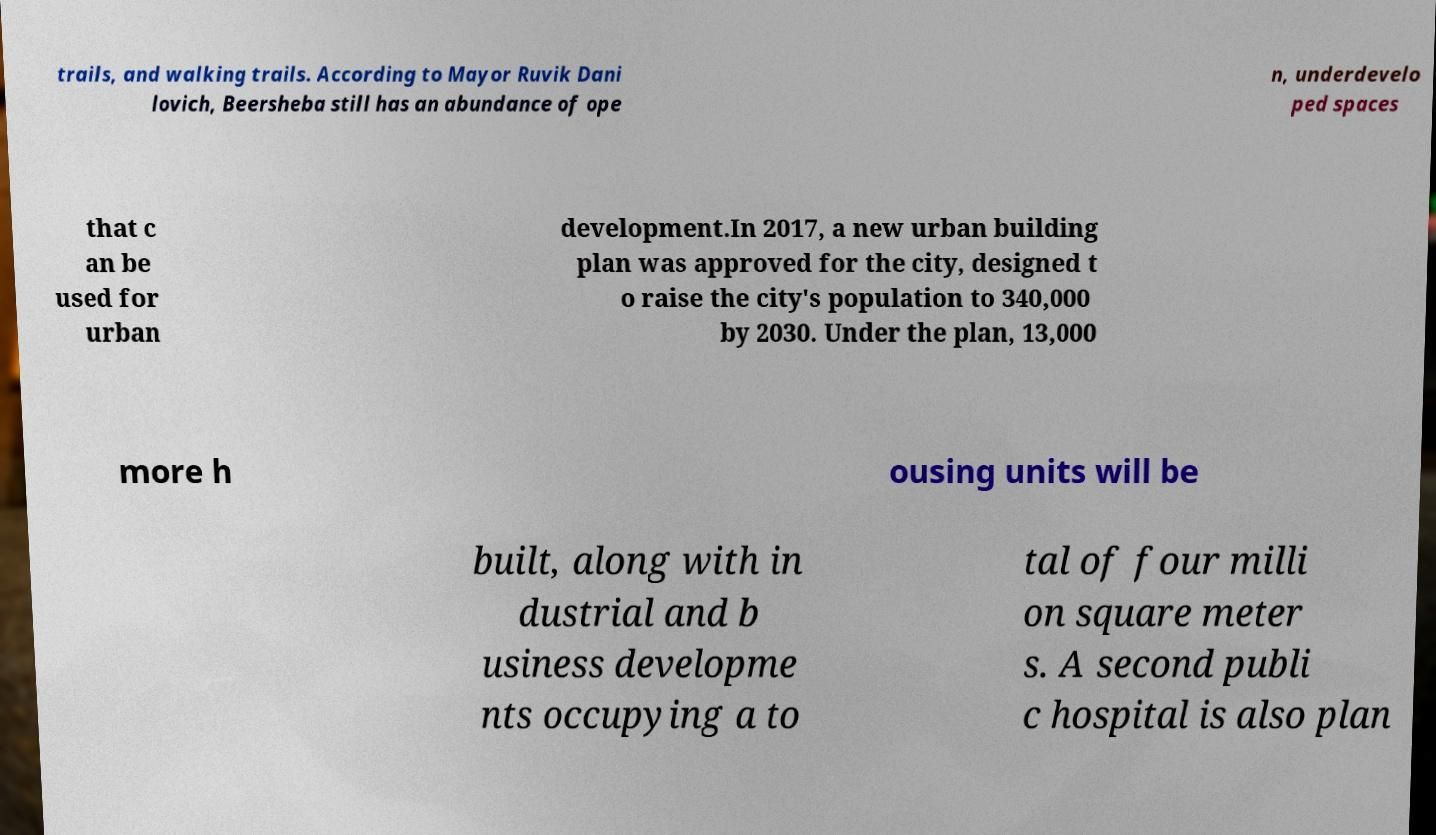Can you accurately transcribe the text from the provided image for me? trails, and walking trails. According to Mayor Ruvik Dani lovich, Beersheba still has an abundance of ope n, underdevelo ped spaces that c an be used for urban development.In 2017, a new urban building plan was approved for the city, designed t o raise the city's population to 340,000 by 2030. Under the plan, 13,000 more h ousing units will be built, along with in dustrial and b usiness developme nts occupying a to tal of four milli on square meter s. A second publi c hospital is also plan 